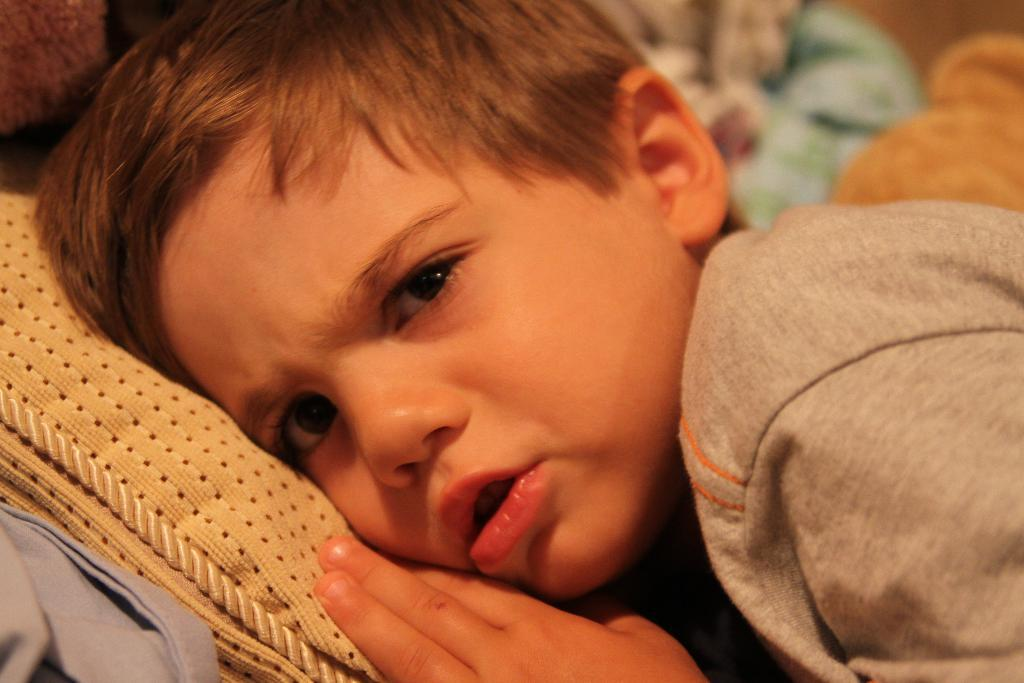What is the main subject of the image? The main subject of the image is a kid. What is the kid doing in the image? The kid is laying on a cloth. Can you describe the background of the image? The background of the image is blurred. How many apples are visible on the copper cabbage in the image? There are no apples or copper cabbage present in the image. 